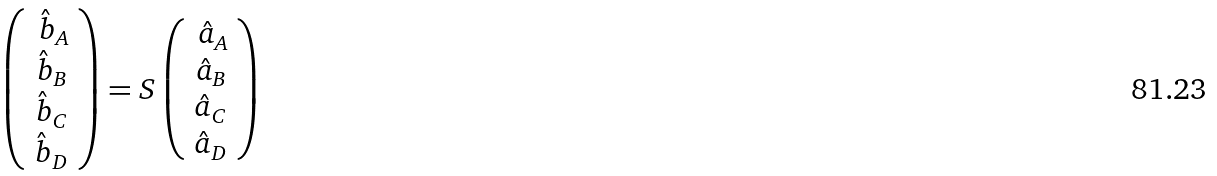<formula> <loc_0><loc_0><loc_500><loc_500>\left ( \begin{array} { r } \hat { b } _ { A } \\ \hat { b } _ { B } \\ \hat { b } _ { C } \\ \hat { b } _ { D } \end{array} \right ) = S \left ( \begin{array} { r } \hat { a } _ { A } \\ \hat { a } _ { B } \\ \hat { a } _ { C } \\ \hat { a } _ { D } \end{array} \right )</formula> 